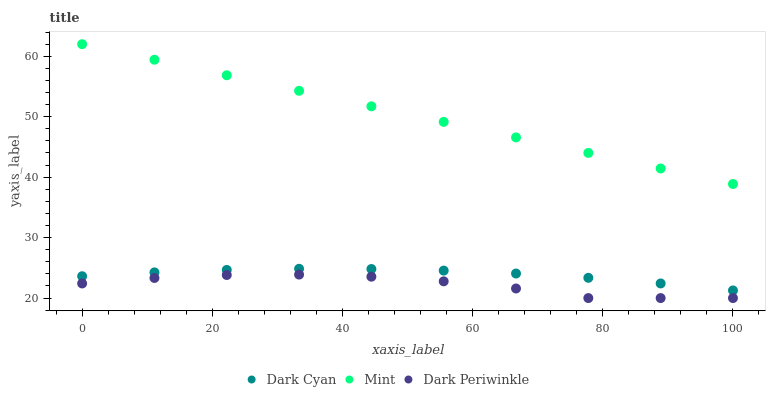Does Dark Periwinkle have the minimum area under the curve?
Answer yes or no. Yes. Does Mint have the maximum area under the curve?
Answer yes or no. Yes. Does Mint have the minimum area under the curve?
Answer yes or no. No. Does Dark Periwinkle have the maximum area under the curve?
Answer yes or no. No. Is Mint the smoothest?
Answer yes or no. Yes. Is Dark Periwinkle the roughest?
Answer yes or no. Yes. Is Dark Periwinkle the smoothest?
Answer yes or no. No. Is Mint the roughest?
Answer yes or no. No. Does Dark Periwinkle have the lowest value?
Answer yes or no. Yes. Does Mint have the lowest value?
Answer yes or no. No. Does Mint have the highest value?
Answer yes or no. Yes. Does Dark Periwinkle have the highest value?
Answer yes or no. No. Is Dark Periwinkle less than Dark Cyan?
Answer yes or no. Yes. Is Dark Cyan greater than Dark Periwinkle?
Answer yes or no. Yes. Does Dark Periwinkle intersect Dark Cyan?
Answer yes or no. No. 